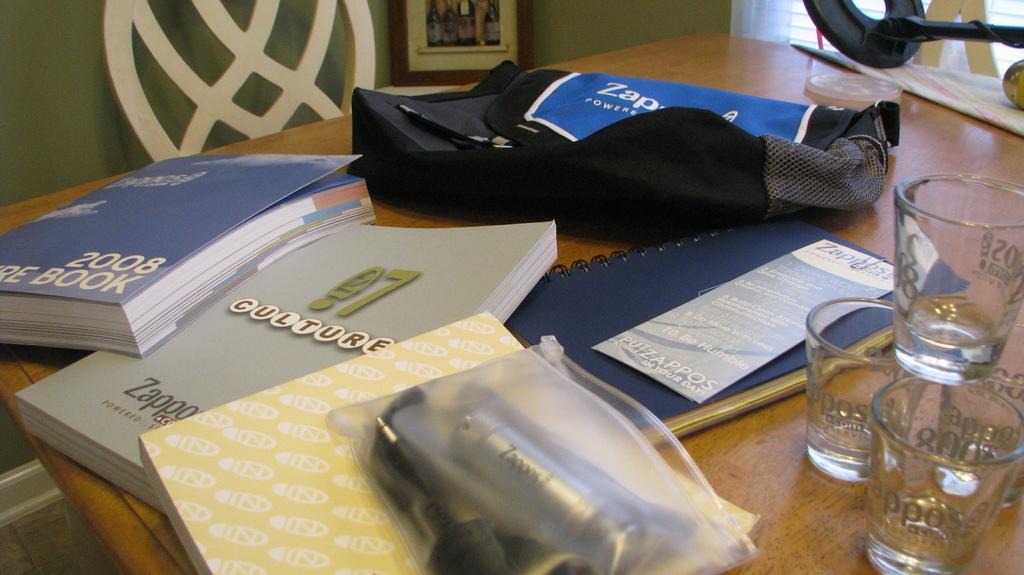Can you describe this image briefly? In this image there is a floor at the bottom. There is a table and there are books, glasses, bags and other objects on the table in the foreground. There is a window, curtain in the right corner. There is a chair, frame, wall in the background. 